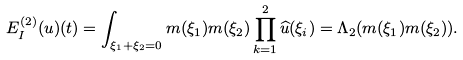Convert formula to latex. <formula><loc_0><loc_0><loc_500><loc_500>E _ { I } ^ { ( 2 ) } ( u ) ( t ) = \int _ { \xi _ { 1 } + \xi _ { 2 } = 0 } m ( \xi _ { 1 } ) m ( \xi _ { 2 } ) \prod _ { k = 1 } ^ { 2 } \widehat { u } ( \xi _ { i } ) = \Lambda _ { 2 } ( m ( \xi _ { 1 } ) m ( \xi _ { 2 } ) ) .</formula> 